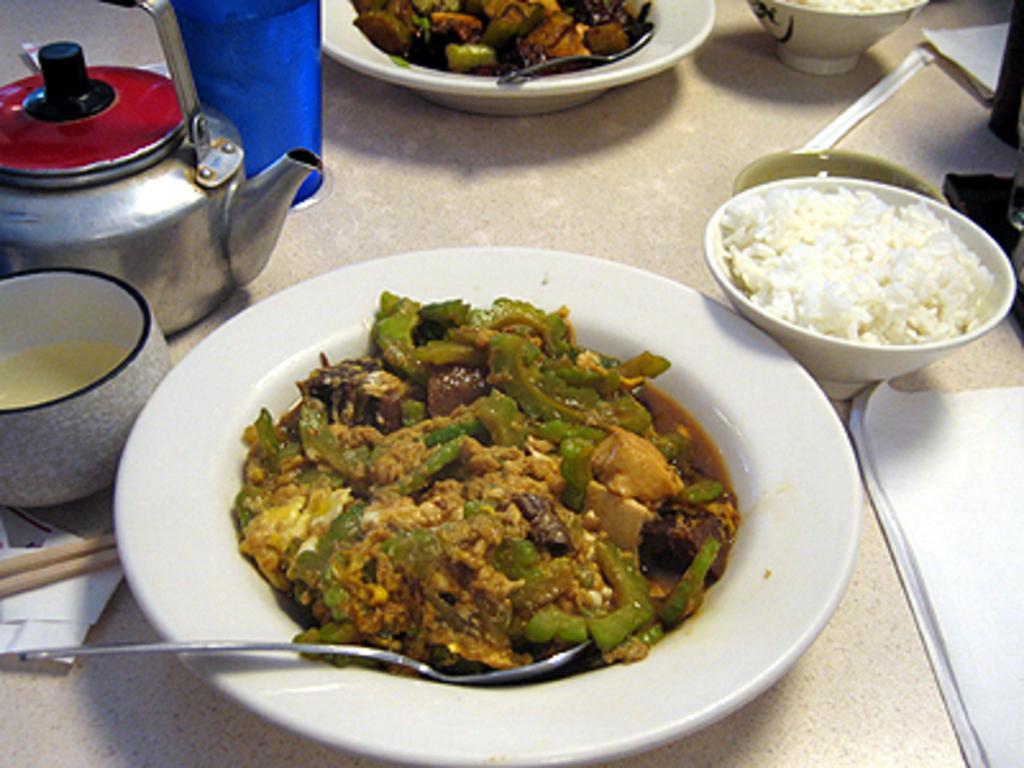Describe this image in one or two sentences. In this picture I can see there is a plate of food placed in the plate and there is a kettle and a there is some other plate with food. 